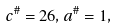Convert formula to latex. <formula><loc_0><loc_0><loc_500><loc_500>c ^ { \# } = 2 6 , a ^ { \# } = 1 ,</formula> 